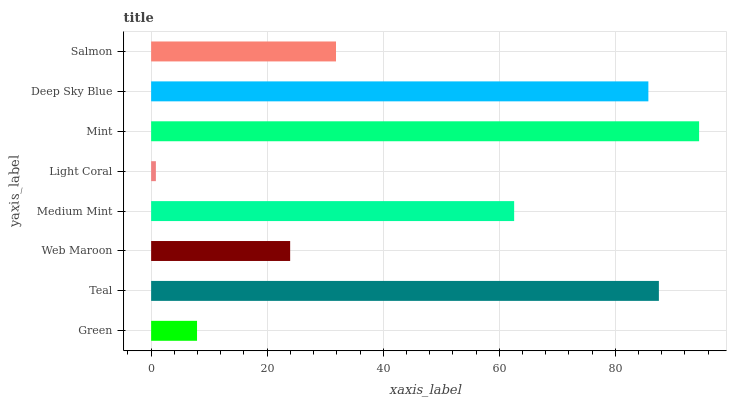Is Light Coral the minimum?
Answer yes or no. Yes. Is Mint the maximum?
Answer yes or no. Yes. Is Teal the minimum?
Answer yes or no. No. Is Teal the maximum?
Answer yes or no. No. Is Teal greater than Green?
Answer yes or no. Yes. Is Green less than Teal?
Answer yes or no. Yes. Is Green greater than Teal?
Answer yes or no. No. Is Teal less than Green?
Answer yes or no. No. Is Medium Mint the high median?
Answer yes or no. Yes. Is Salmon the low median?
Answer yes or no. Yes. Is Light Coral the high median?
Answer yes or no. No. Is Medium Mint the low median?
Answer yes or no. No. 